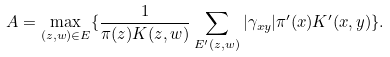Convert formula to latex. <formula><loc_0><loc_0><loc_500><loc_500>A = \max _ { ( z , w ) \in E } \{ \frac { 1 } { \pi ( z ) K ( z , w ) } \sum _ { E ^ { \prime } ( z , w ) } | \gamma _ { x y } | \pi ^ { \prime } ( x ) K ^ { \prime } ( x , y ) \} .</formula> 